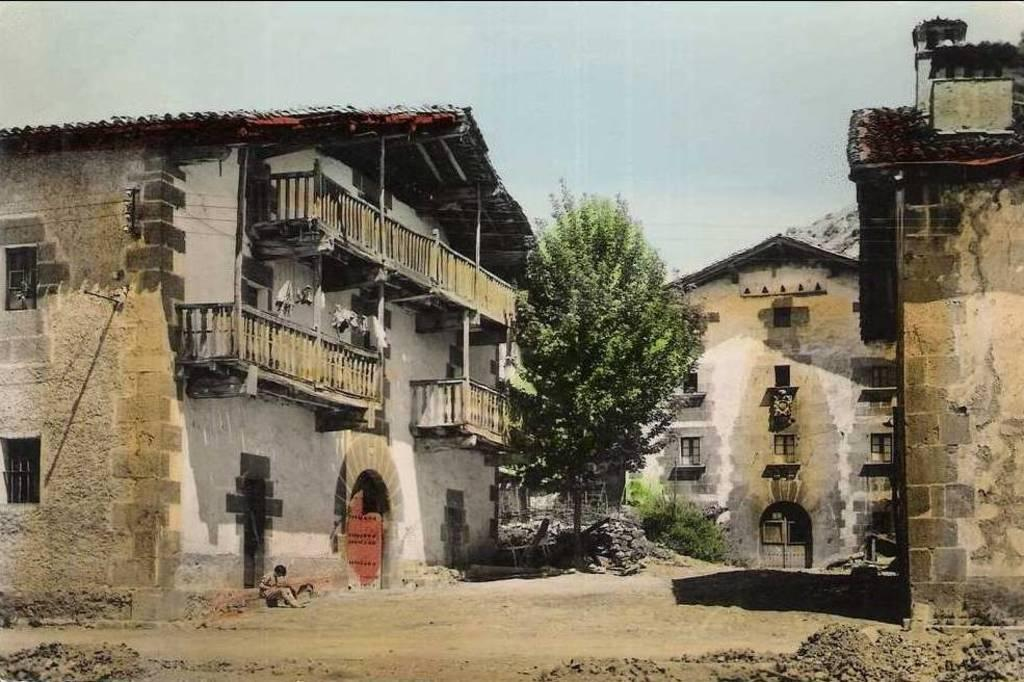What type of structures are present in the image? There are buildings with windows and doors in the image. What natural element can be seen in the image? There is a tree in the image. Are there any other living organisms besides the tree in the image? Yes, there are plants in the image. How many sisters are holding boots in the image? There are no sisters or boots present in the image. 